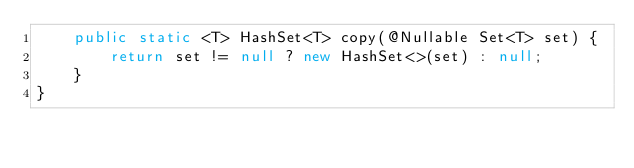Convert code to text. <code><loc_0><loc_0><loc_500><loc_500><_Java_>    public static <T> HashSet<T> copy(@Nullable Set<T> set) {
        return set != null ? new HashSet<>(set) : null;
    }
}
</code> 